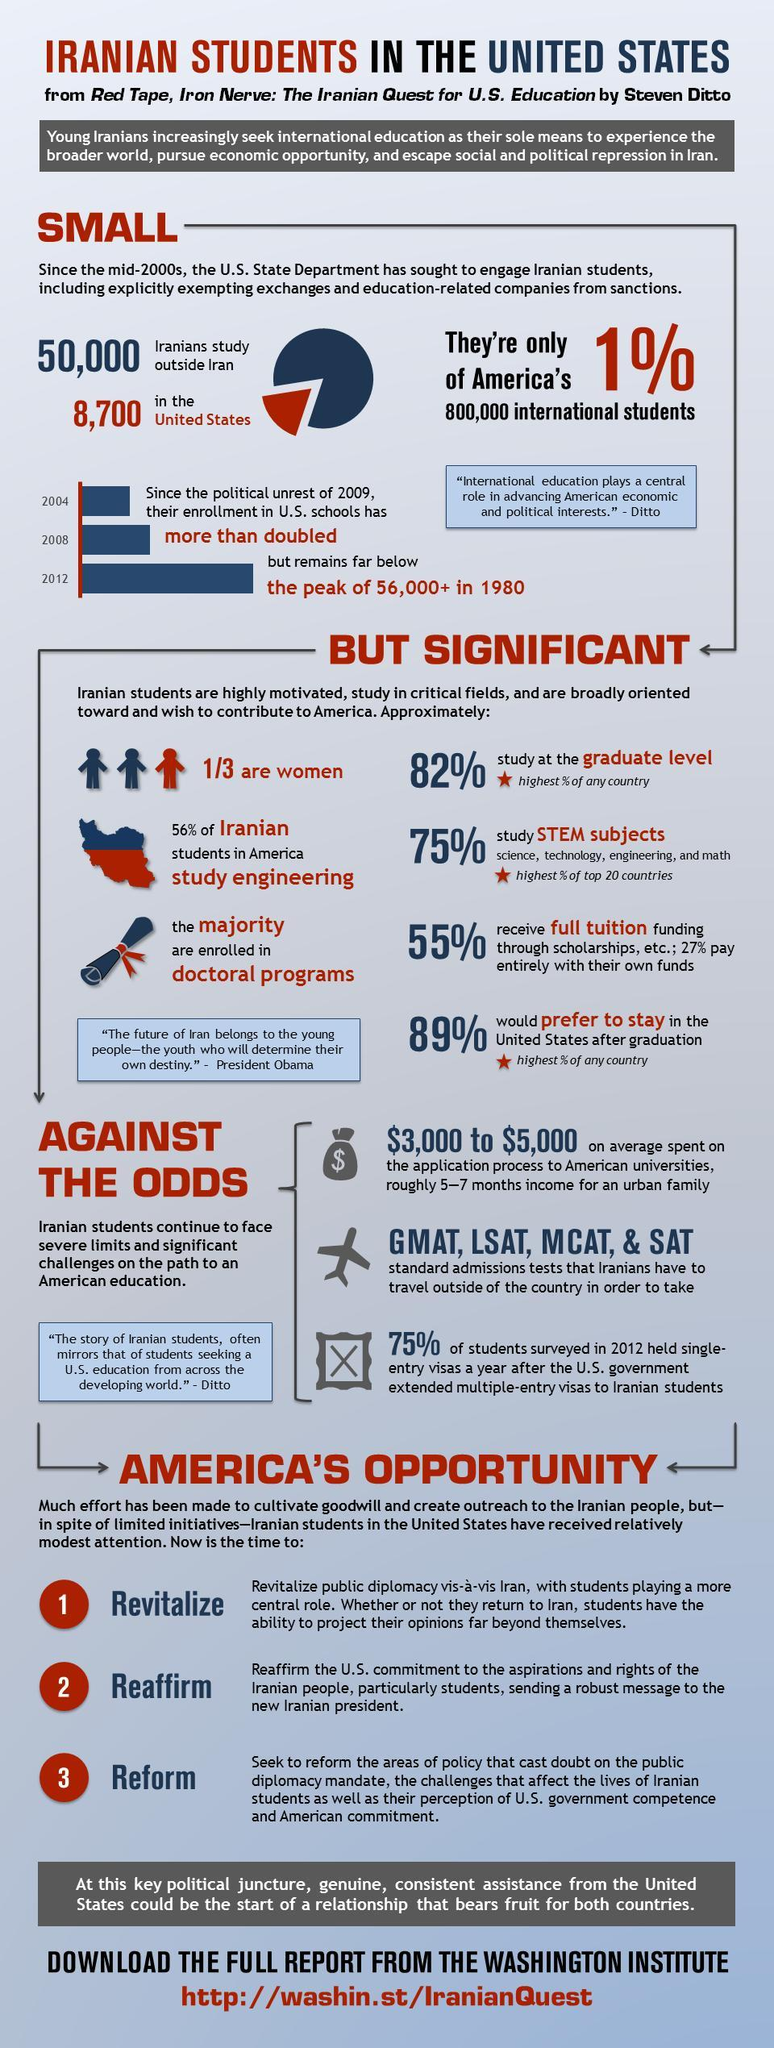What is the no of iranians studying in the U.S.?
Answer the question with a short phrase. 8,700 What percent of iranian students study stem subjects? 75% What is the average money spent by iranian students on the application process to American  universities? $3,000 to $5,000 What percent of iranian students do not prefer to stay in the U.S. after graduation? 11% What percent of iranian students study at the graduate level? 82% What is the no of iranians studying outside Iran? 50,000 